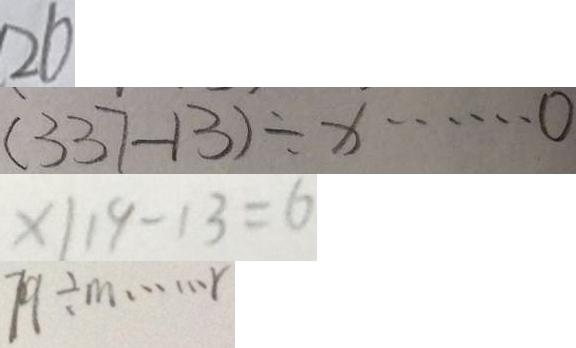Convert formula to latex. <formula><loc_0><loc_0><loc_500><loc_500>2 6 
 ( 3 3 7 - 1 3 ) \div x \cdots 0 
 x \vert 1 9 - 1 3 = 6 
 7 9 \div m \cdots r</formula> 